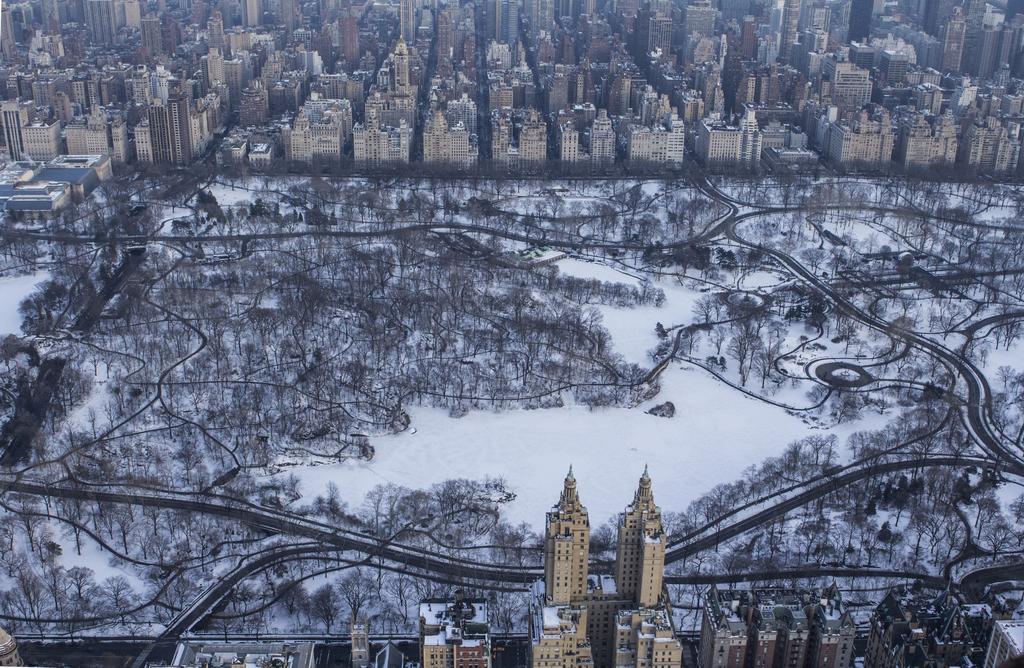What is the predominant weather condition in the image? There is snow in the image, indicating a wintery or cold weather condition. What type of natural elements can be seen in the image? There are trees in the image. What type of man-made structures can be seen in the image? There are buildings at the top and bottom of the image, and there are roads visible as well. How many eggs are hanging from the icicles in the image? There are no eggs or icicles present in the image. What type of judgment is the judge making in the image? There is no judge present in the image, so no judgment can be made. 